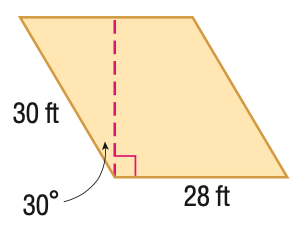Question: Find the area of the parallelogram. Round to the nearest tenth if necessary.
Choices:
A. 420
B. 594.0
C. 727.5
D. 840
Answer with the letter. Answer: C 